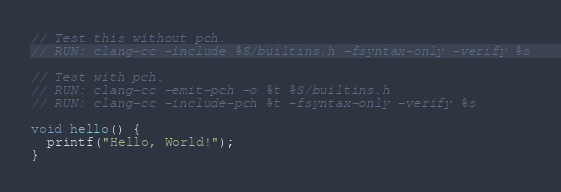<code> <loc_0><loc_0><loc_500><loc_500><_C_>// Test this without pch.
// RUN: clang-cc -include %S/builtins.h -fsyntax-only -verify %s

// Test with pch.
// RUN: clang-cc -emit-pch -o %t %S/builtins.h
// RUN: clang-cc -include-pch %t -fsyntax-only -verify %s 

void hello() {
  printf("Hello, World!");
}
</code> 